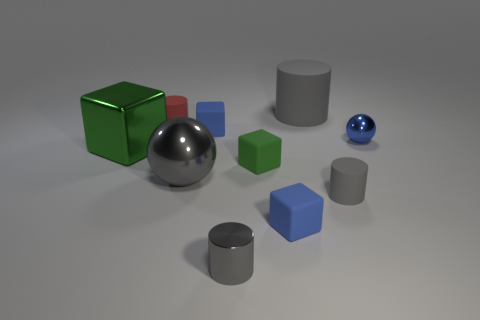There is a block that is in front of the blue metallic object and to the left of the small gray metallic thing; what size is it?
Give a very brief answer. Large. There is a tiny blue thing left of the small gray thing on the left side of the small gray matte cylinder; what is its shape?
Give a very brief answer. Cube. Is there anything else that is the same shape as the blue metal thing?
Your response must be concise. Yes. Are there an equal number of matte cylinders that are in front of the metallic cylinder and small green spheres?
Make the answer very short. Yes. There is a large ball; does it have the same color as the small metallic object in front of the green metal thing?
Make the answer very short. Yes. What color is the cylinder that is both behind the tiny blue metallic ball and in front of the big gray cylinder?
Keep it short and to the point. Red. How many tiny cylinders are in front of the blue matte thing on the left side of the metallic cylinder?
Your answer should be compact. 2. Is there a tiny cyan metal object of the same shape as the red matte thing?
Offer a very short reply. No. Is the shape of the green object that is to the left of the small green cube the same as the large metal object that is to the right of the big metal block?
Your answer should be compact. No. What number of things are either large purple cubes or blue objects?
Offer a terse response. 3. 